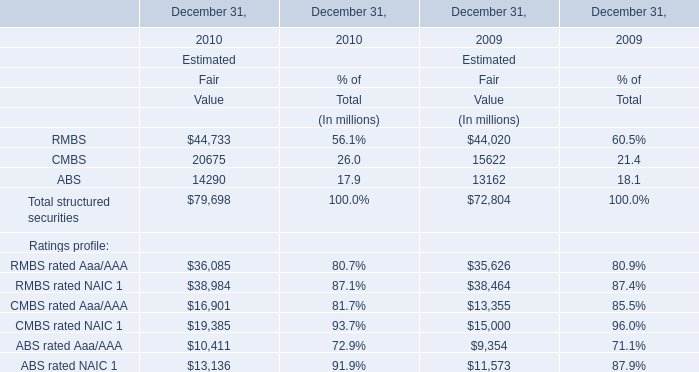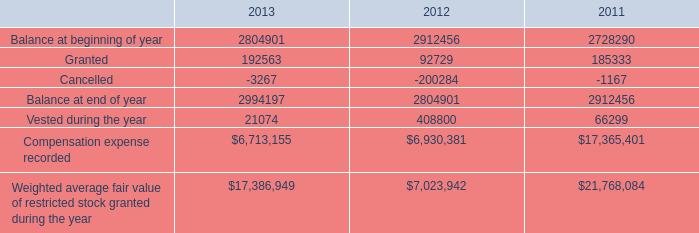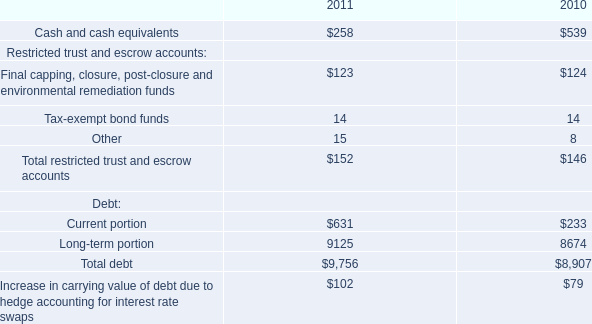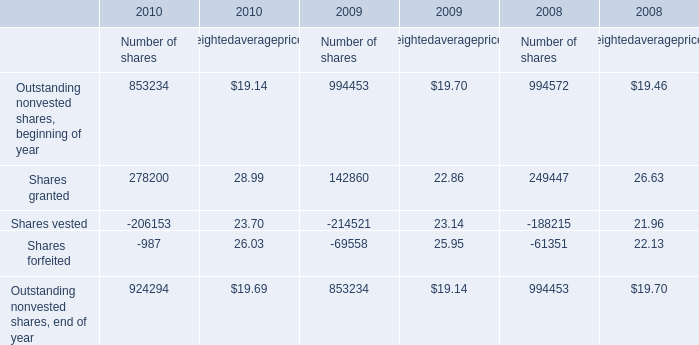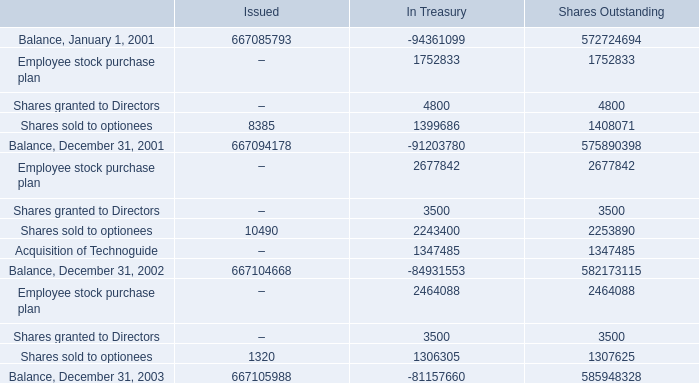What is the total amount of Balance, December 31, 2002 of Shares Outstanding, Balance at beginning of year of 2012, and Outstanding nonvested shares, end of year of 2008 Number of shares ? 
Computations: ((582173115.0 + 2912456.0) + 994453.0)
Answer: 586080024.0. 